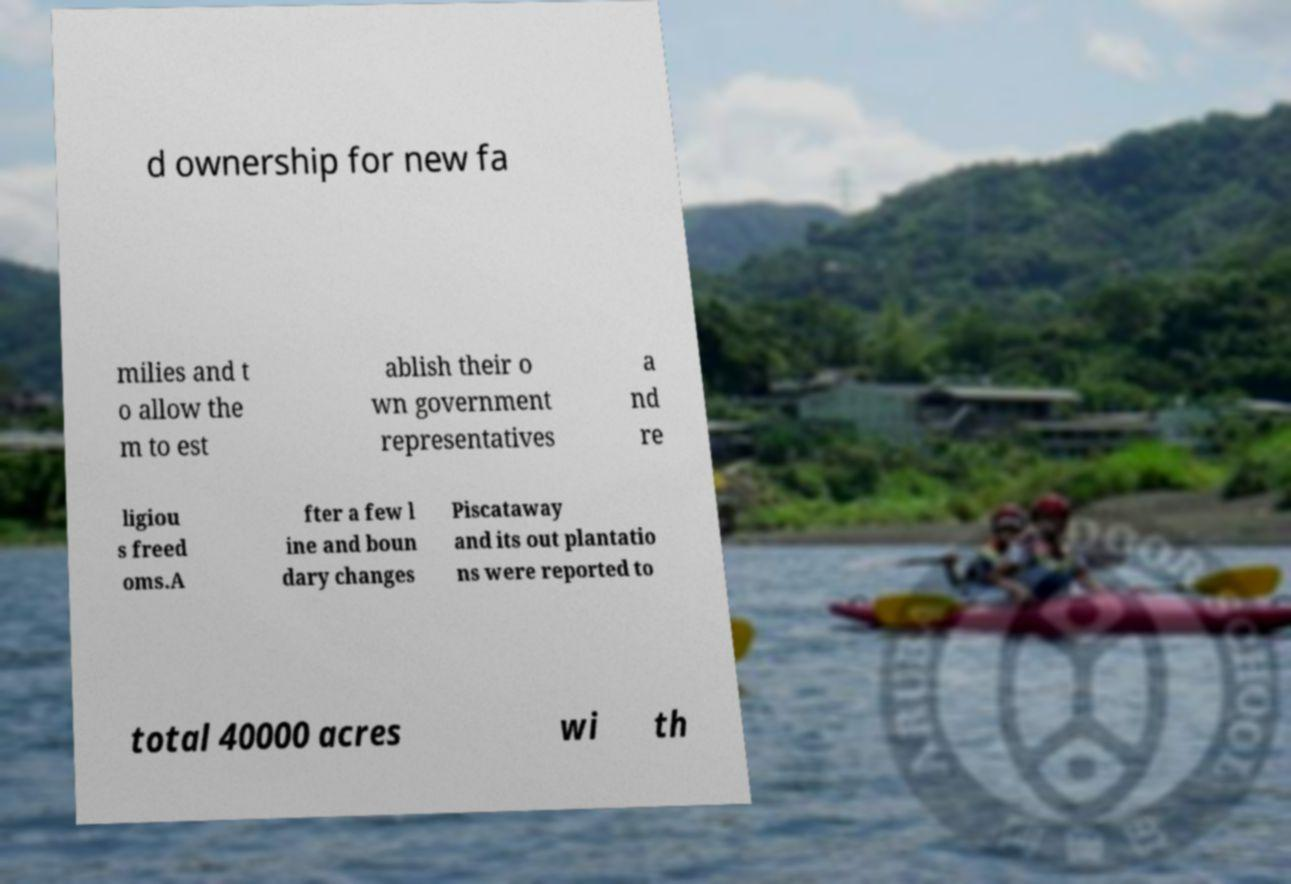For documentation purposes, I need the text within this image transcribed. Could you provide that? d ownership for new fa milies and t o allow the m to est ablish their o wn government representatives a nd re ligiou s freed oms.A fter a few l ine and boun dary changes Piscataway and its out plantatio ns were reported to total 40000 acres wi th 